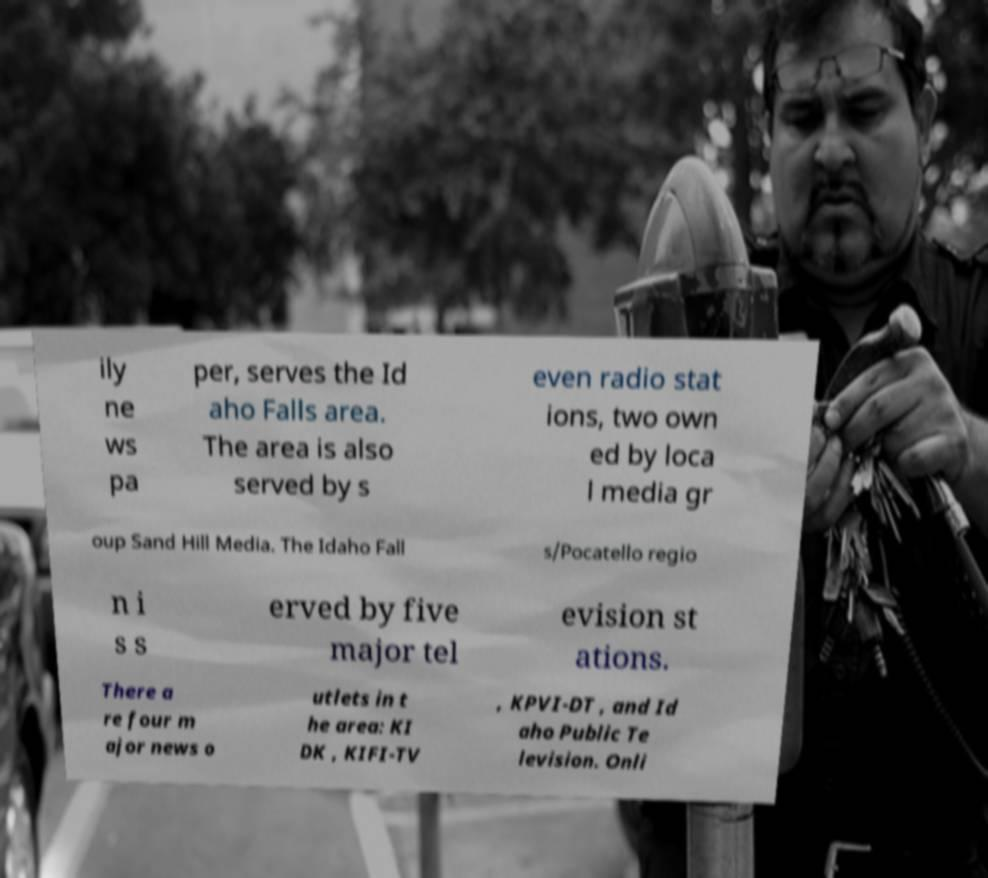Please identify and transcribe the text found in this image. ily ne ws pa per, serves the Id aho Falls area. The area is also served by s even radio stat ions, two own ed by loca l media gr oup Sand Hill Media. The Idaho Fall s/Pocatello regio n i s s erved by five major tel evision st ations. There a re four m ajor news o utlets in t he area: KI DK , KIFI-TV , KPVI-DT , and Id aho Public Te levision. Onli 